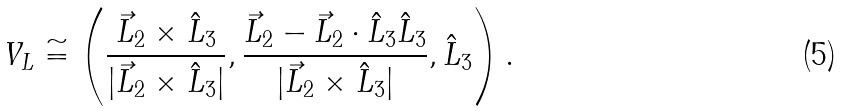<formula> <loc_0><loc_0><loc_500><loc_500>V _ { L } \cong \left ( \frac { \vec { L } _ { 2 } \times \hat { L } _ { 3 } } { | \vec { L } _ { 2 } \times \hat { L } _ { 3 } | } , \frac { \vec { L } _ { 2 } - \vec { L } _ { 2 } \cdot \hat { L } _ { 3 } \hat { L } _ { 3 } } { | \vec { L } _ { 2 } \times \hat { L } _ { 3 } | } , \hat { L } _ { 3 } \right ) .</formula> 